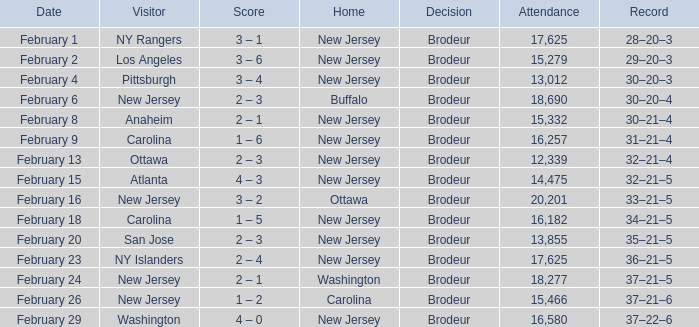What was the result when the guest team was ottawa? 32–21–4. Could you parse the entire table as a dict? {'header': ['Date', 'Visitor', 'Score', 'Home', 'Decision', 'Attendance', 'Record'], 'rows': [['February 1', 'NY Rangers', '3 – 1', 'New Jersey', 'Brodeur', '17,625', '28–20–3'], ['February 2', 'Los Angeles', '3 – 6', 'New Jersey', 'Brodeur', '15,279', '29–20–3'], ['February 4', 'Pittsburgh', '3 – 4', 'New Jersey', 'Brodeur', '13,012', '30–20–3'], ['February 6', 'New Jersey', '2 – 3', 'Buffalo', 'Brodeur', '18,690', '30–20–4'], ['February 8', 'Anaheim', '2 – 1', 'New Jersey', 'Brodeur', '15,332', '30–21–4'], ['February 9', 'Carolina', '1 – 6', 'New Jersey', 'Brodeur', '16,257', '31–21–4'], ['February 13', 'Ottawa', '2 – 3', 'New Jersey', 'Brodeur', '12,339', '32–21–4'], ['February 15', 'Atlanta', '4 – 3', 'New Jersey', 'Brodeur', '14,475', '32–21–5'], ['February 16', 'New Jersey', '3 – 2', 'Ottawa', 'Brodeur', '20,201', '33–21–5'], ['February 18', 'Carolina', '1 – 5', 'New Jersey', 'Brodeur', '16,182', '34–21–5'], ['February 20', 'San Jose', '2 – 3', 'New Jersey', 'Brodeur', '13,855', '35–21–5'], ['February 23', 'NY Islanders', '2 – 4', 'New Jersey', 'Brodeur', '17,625', '36–21–5'], ['February 24', 'New Jersey', '2 – 1', 'Washington', 'Brodeur', '18,277', '37–21–5'], ['February 26', 'New Jersey', '1 – 2', 'Carolina', 'Brodeur', '15,466', '37–21–6'], ['February 29', 'Washington', '4 – 0', 'New Jersey', 'Brodeur', '16,580', '37–22–6']]} 